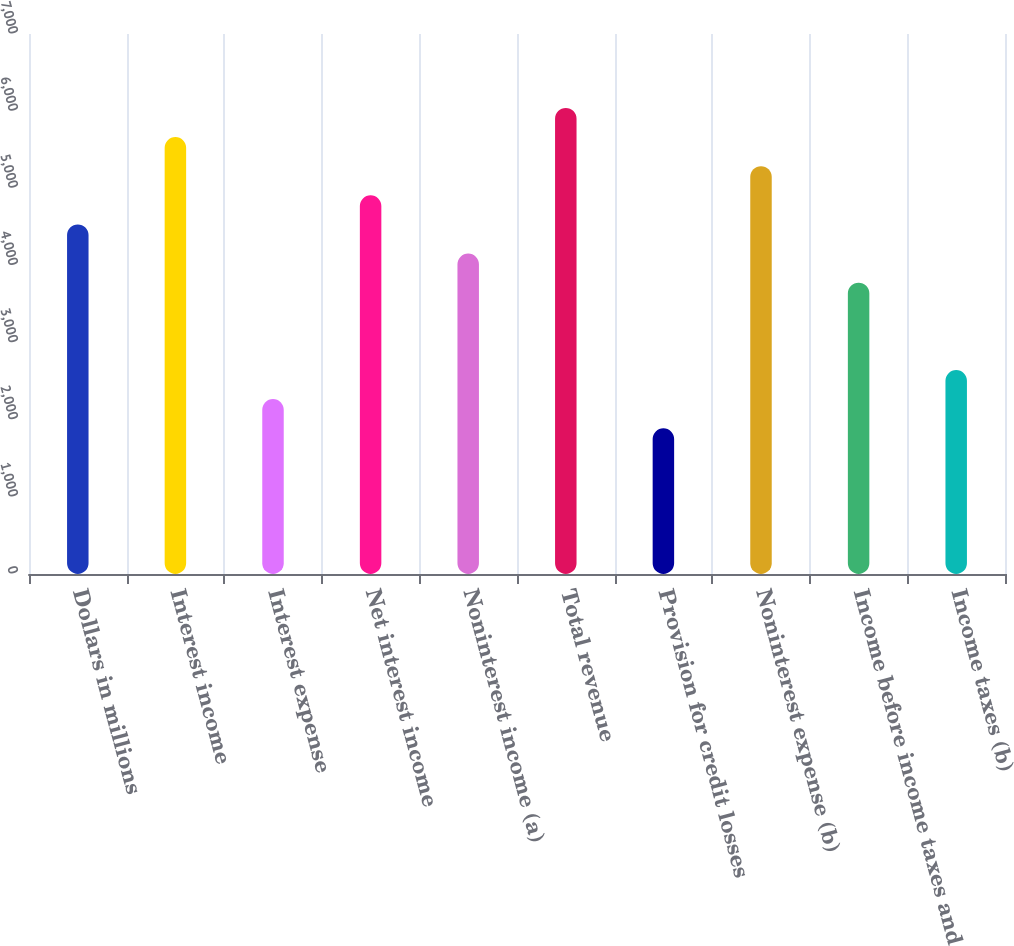Convert chart to OTSL. <chart><loc_0><loc_0><loc_500><loc_500><bar_chart><fcel>Dollars in millions<fcel>Interest income<fcel>Interest expense<fcel>Net interest income<fcel>Noninterest income (a)<fcel>Total revenue<fcel>Provision for credit losses<fcel>Noninterest expense (b)<fcel>Income before income taxes and<fcel>Income taxes (b)<nl><fcel>4532.06<fcel>5664.62<fcel>2266.94<fcel>4909.58<fcel>4154.54<fcel>6042.14<fcel>1889.42<fcel>5287.1<fcel>3777.02<fcel>2644.46<nl></chart> 